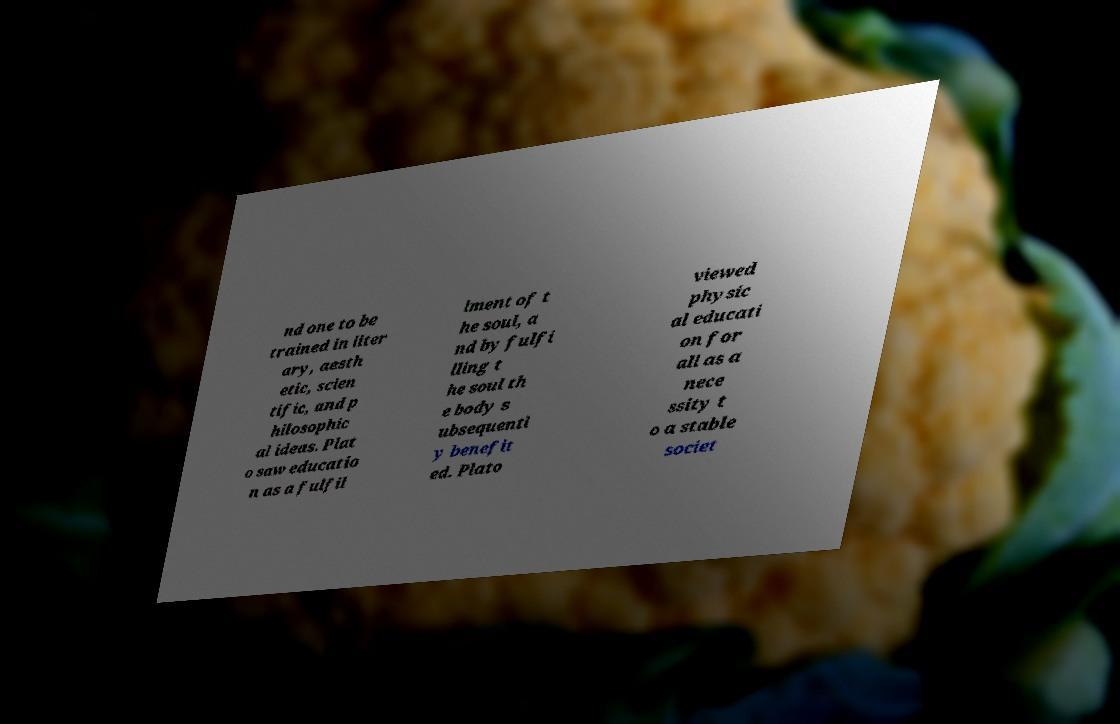For documentation purposes, I need the text within this image transcribed. Could you provide that? nd one to be trained in liter ary, aesth etic, scien tific, and p hilosophic al ideas. Plat o saw educatio n as a fulfil lment of t he soul, a nd by fulfi lling t he soul th e body s ubsequentl y benefit ed. Plato viewed physic al educati on for all as a nece ssity t o a stable societ 